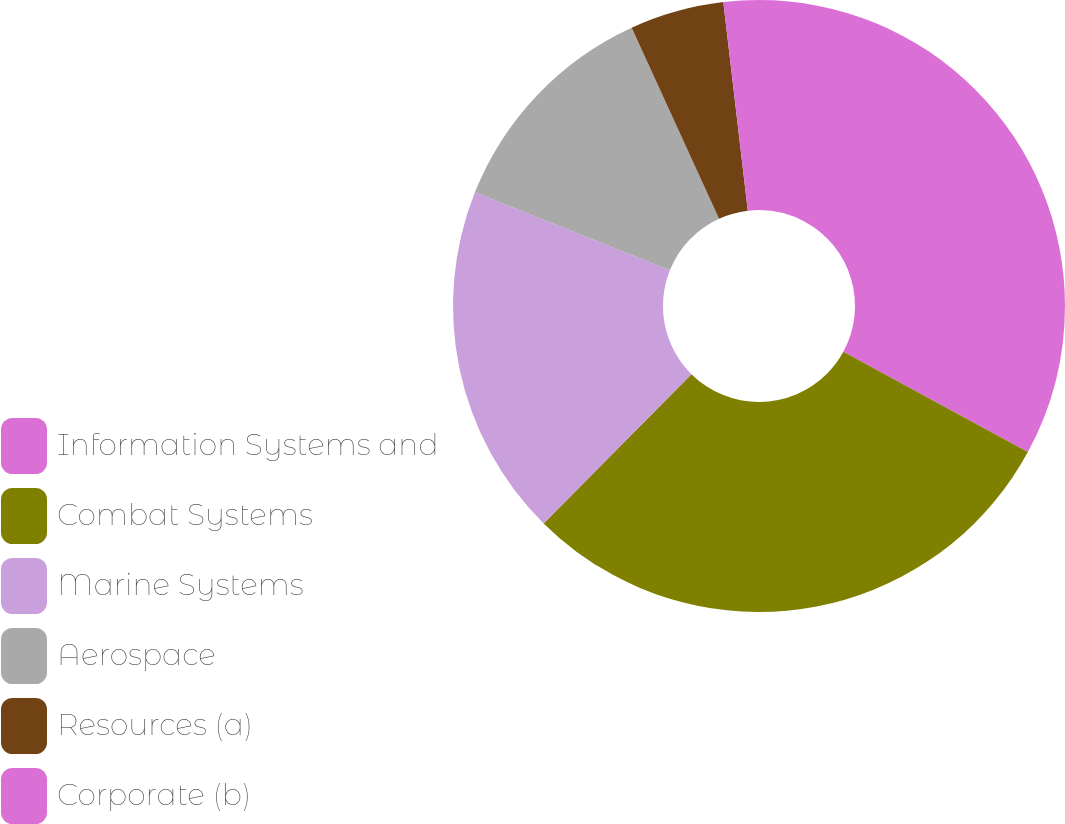<chart> <loc_0><loc_0><loc_500><loc_500><pie_chart><fcel>Information Systems and<fcel>Combat Systems<fcel>Marine Systems<fcel>Aerospace<fcel>Resources (a)<fcel>Corporate (b)<nl><fcel>32.92%<fcel>29.5%<fcel>18.63%<fcel>12.11%<fcel>4.97%<fcel>1.86%<nl></chart> 